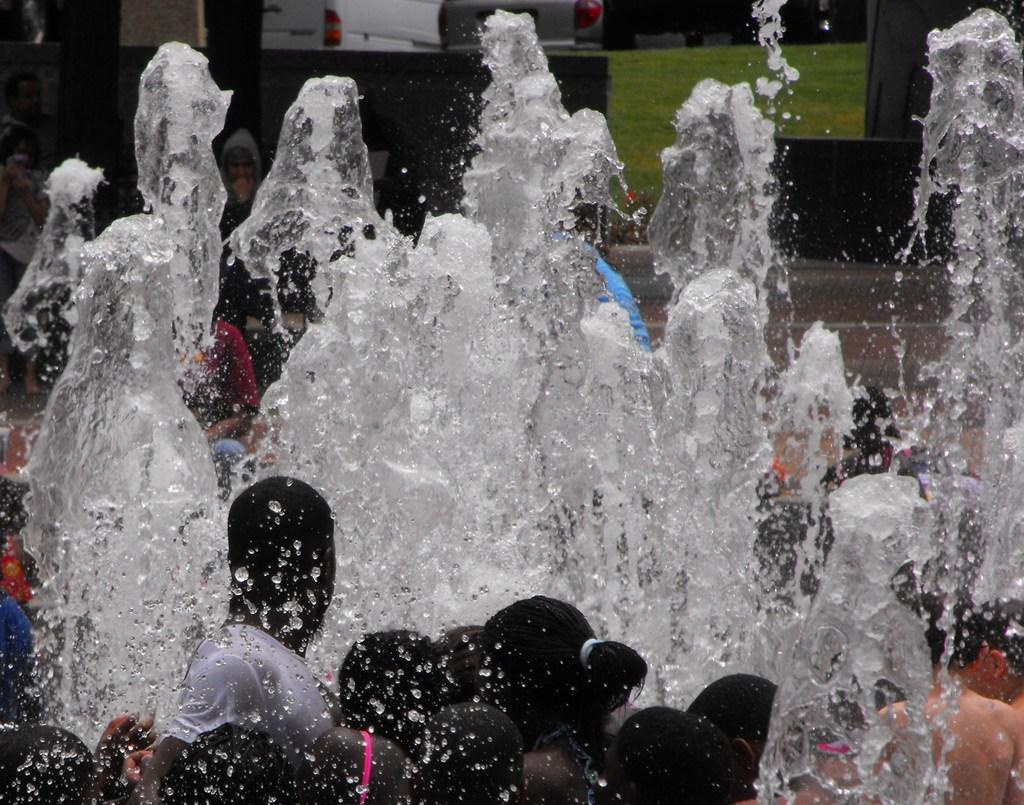How many people are in the image? There are persons in the image, but the exact number is not specified. What is the surrounding environment of the persons? There is water on either side of the persons. What can be seen in the background of the image? There are vehicles in the background of the image. What type of error can be seen in the image? There is no error present in the image. Is there a bomb visible in the image? There is no bomb present in the image. 